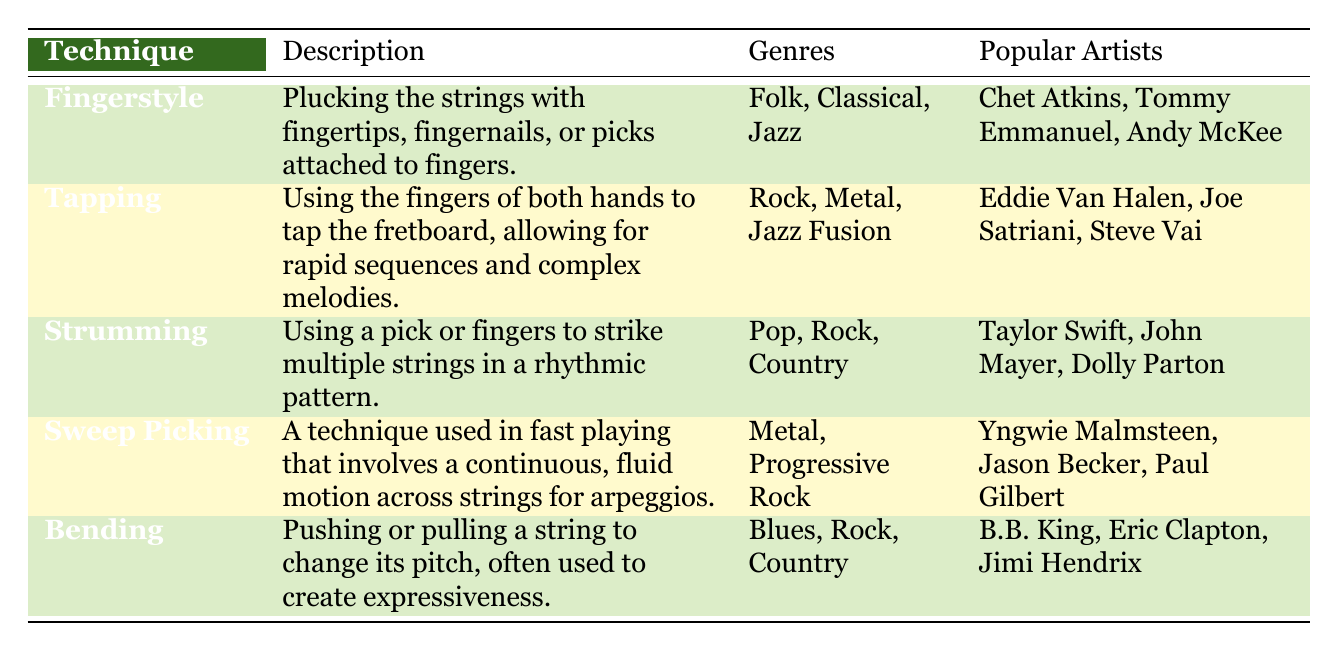What guitar technique is commonly associated with the genres of Folk, Classical, and Jazz? The table lists the genres for each guitar technique. Looking at the "Genres" column, the technique that includes Folk, Classical, and Jazz is "Fingerstyle."
Answer: Fingerstyle Which popular artist is known for using the Tapping technique? From the "Popular Artists" column associated with the "Tapping" technique, Eddie Van Halen is one of the artists mentioned.
Answer: Eddie Van Halen Are Strumming and Bending techniques used in the same genres? By examining the genres listed for "Strumming" (Pop, Rock, Country) and "Bending" (Blues, Rock, Country), it shows that both techniques are used in the genre of Rock, confirming they overlap.
Answer: Yes How many techniques are associated with the Metal genre? The genres associated with each technique are listed, and both "Tapping" and "Sweep Picking" are in the Metal genre, making the count two.
Answer: 2 Which technique has the most popular artists listed? Each technique has a set number of artists. By visually inspecting the "Popular Artists" for each technique, all techniques list three popular artists, so they are equal.
Answer: All techniques have three artists Does the technique of Sweep Picking appear in any genres outside of Metal and Progressive Rock? The table lists "Genres" for "Sweep Picking" as only Metal and Progressive Rock. Therefore, it does not appear in any other genres.
Answer: No Which guitar technique is specifically described as allowing for rapid sequences and complex melodies? Referring to the "Description" column for each technique, "Tapping" is described as allowing rapid sequences and complex melodies.
Answer: Tapping If you combine the genres for Fingerstyle and Bending techniques, how many unique genres are there? Fingerstyle includes Folk, Classical, Jazz, and Bending includes Blues, Rock, Country. Combining these and filtering for uniqueness results in the following genres: Folk, Classical, Jazz, Blues, Rock, Country, totaling six unique genres.
Answer: 6 What is the primary action used in the Bending technique? The "Description" for "Bending" specifies that it involves pushing or pulling a string to change its pitch.
Answer: Pushing or pulling a string 